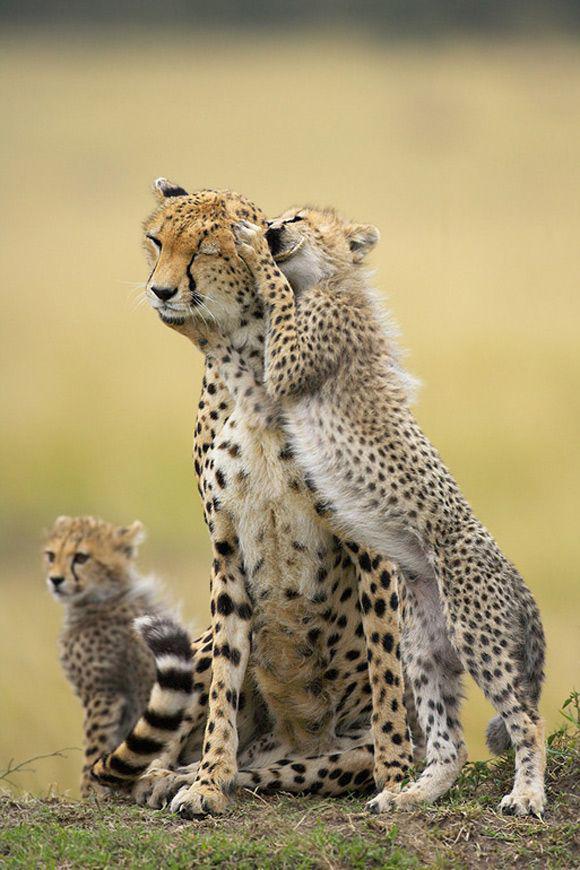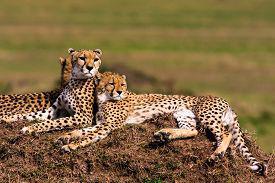The first image is the image on the left, the second image is the image on the right. Examine the images to the left and right. Is the description "One image contains two cheetah kittens and one adult cheetah, and one of the kittens is standing on its hind legs so its head is nearly even with the upright adult cat." accurate? Answer yes or no. Yes. 